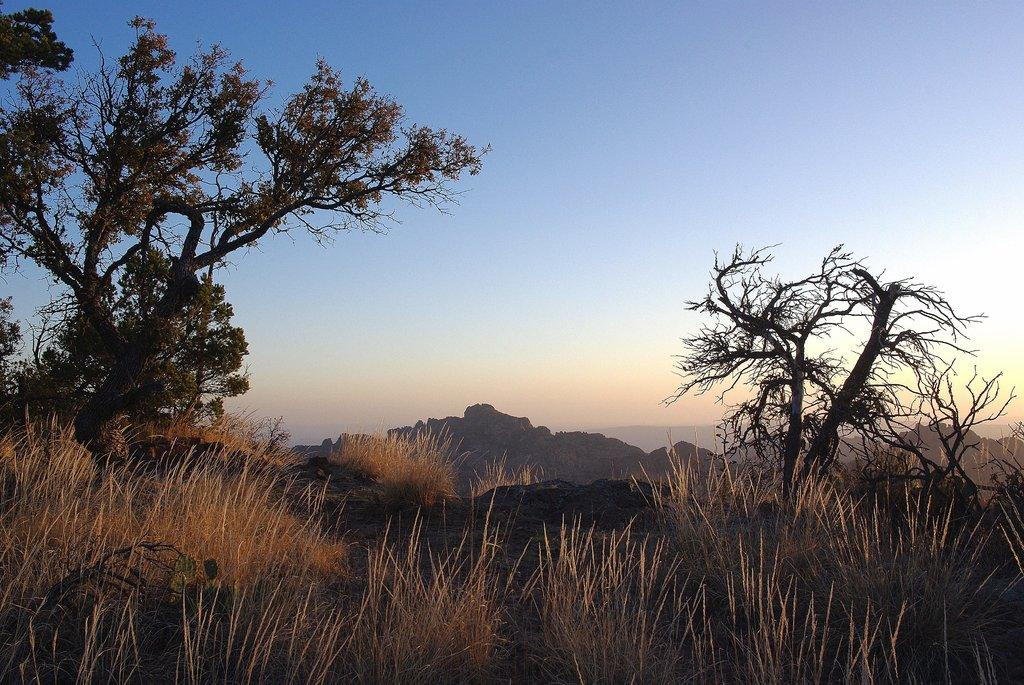What part of the natural environment is visible in the image? The sky is visible in the image. What type of vegetation can be seen in the image? There is a tree and grass present in the image. What type of landscape feature is visible in the image? There is a hill in the image. What type of cloth is being used for the operation in the image? There is no operation or cloth present in the image. What type of test is being conducted in the image? There is no test being conducted in the image. 